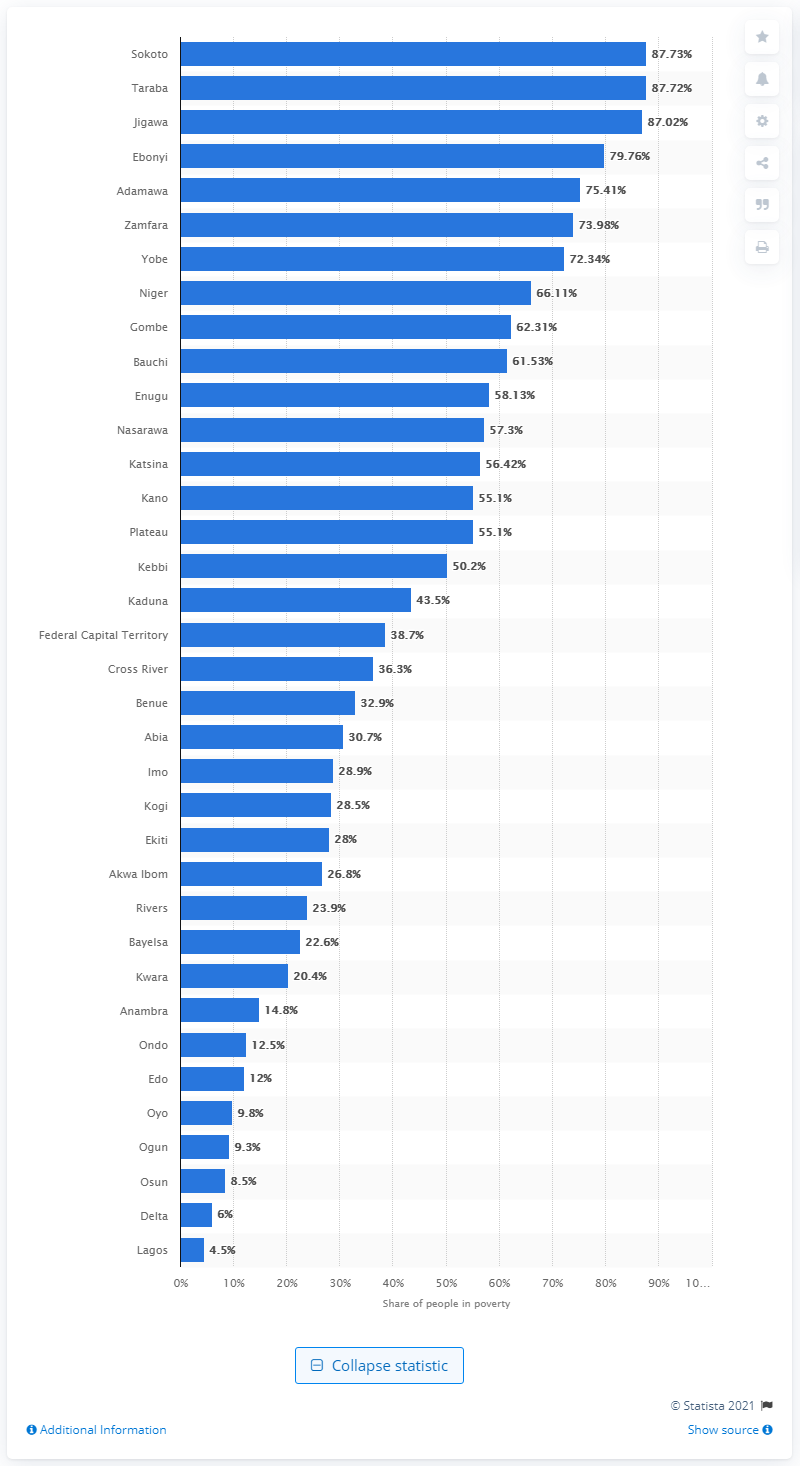Indicate a few pertinent items in this graphic. In 2019, the poverty rate in Lagos was 4.5%. 